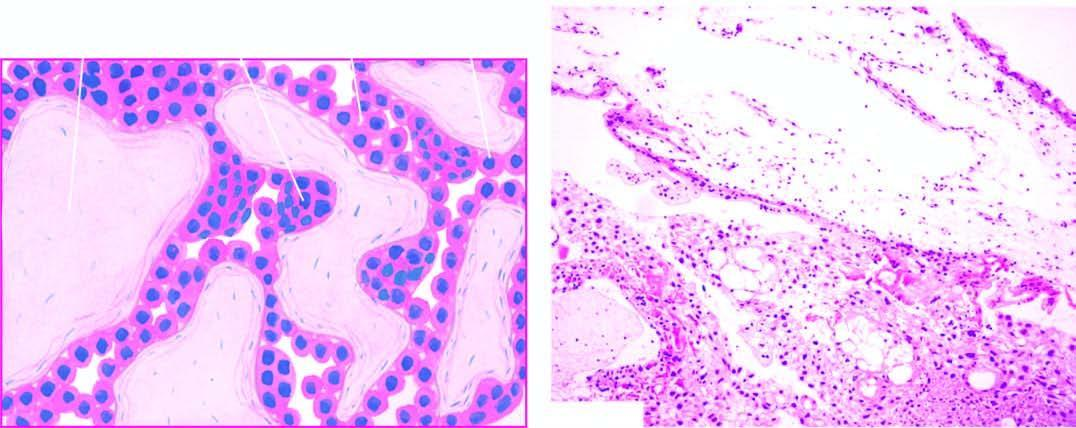s the tumour arising from the retina characterised by hydropic and avascular enlarged villi with trophoblastic proliferation in the form of masses and sheets?
Answer the question using a single word or phrase. No 